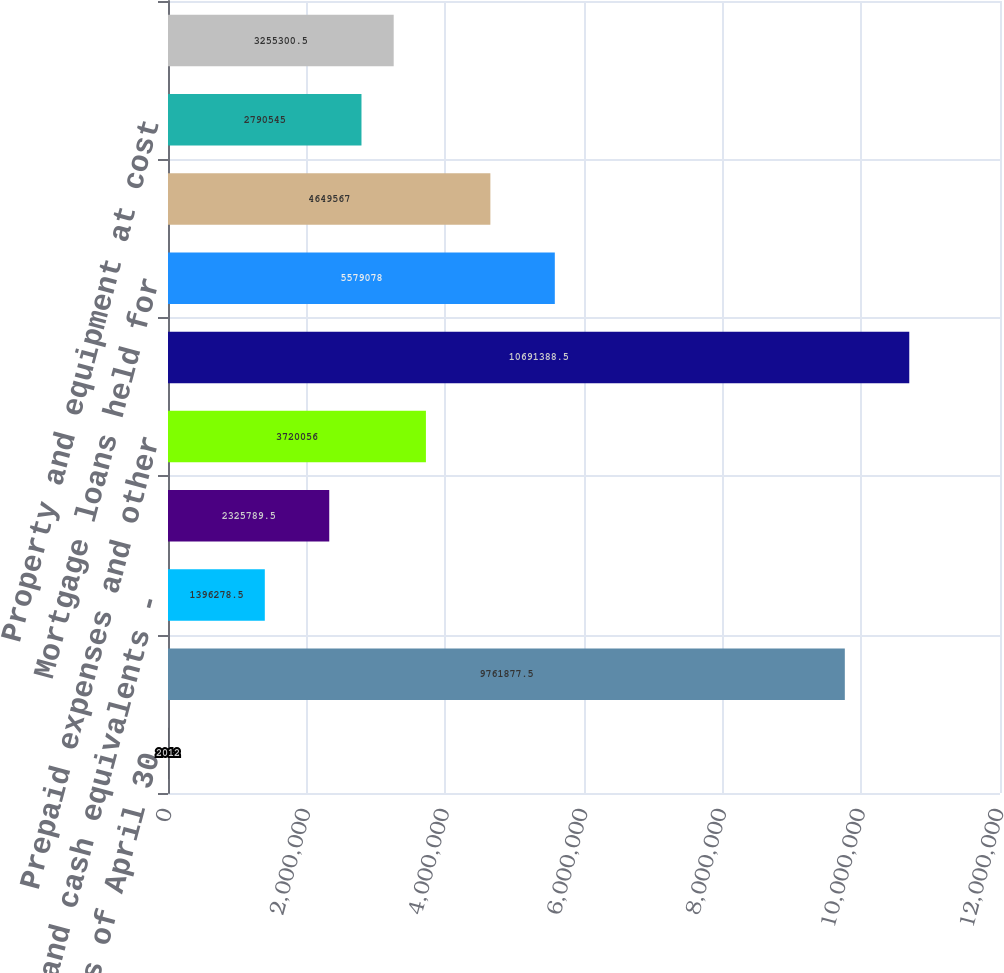<chart> <loc_0><loc_0><loc_500><loc_500><bar_chart><fcel>As of April 30<fcel>Cash and cash equivalents<fcel>Cash and cash equivalents -<fcel>Receivables less allowance for<fcel>Prepaid expenses and other<fcel>Total current assets<fcel>Mortgage loans held for<fcel>Investments in<fcel>Property and equipment at cost<fcel>Intangible assets net<nl><fcel>2012<fcel>9.76188e+06<fcel>1.39628e+06<fcel>2.32579e+06<fcel>3.72006e+06<fcel>1.06914e+07<fcel>5.57908e+06<fcel>4.64957e+06<fcel>2.79054e+06<fcel>3.2553e+06<nl></chart> 